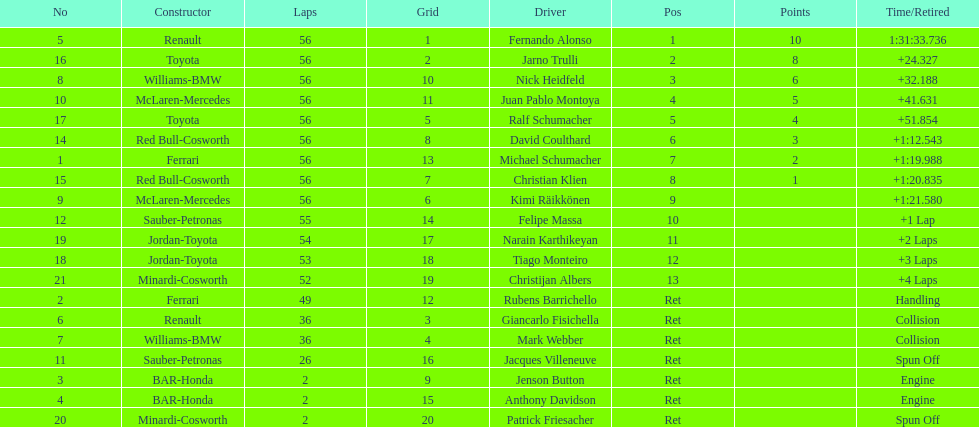How many drivers were retired before the race could end? 7. 